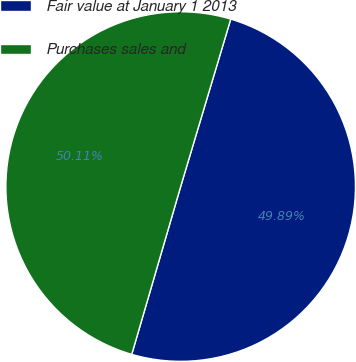<chart> <loc_0><loc_0><loc_500><loc_500><pie_chart><fcel>Fair value at January 1 2013<fcel>Purchases sales and<nl><fcel>49.89%<fcel>50.11%<nl></chart> 